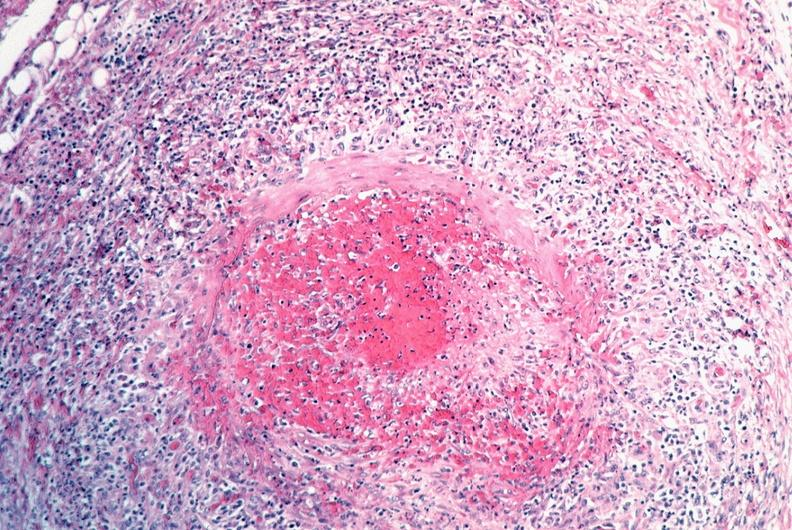does this image show vasculitis, polyarteritis nodosa?
Answer the question using a single word or phrase. Yes 